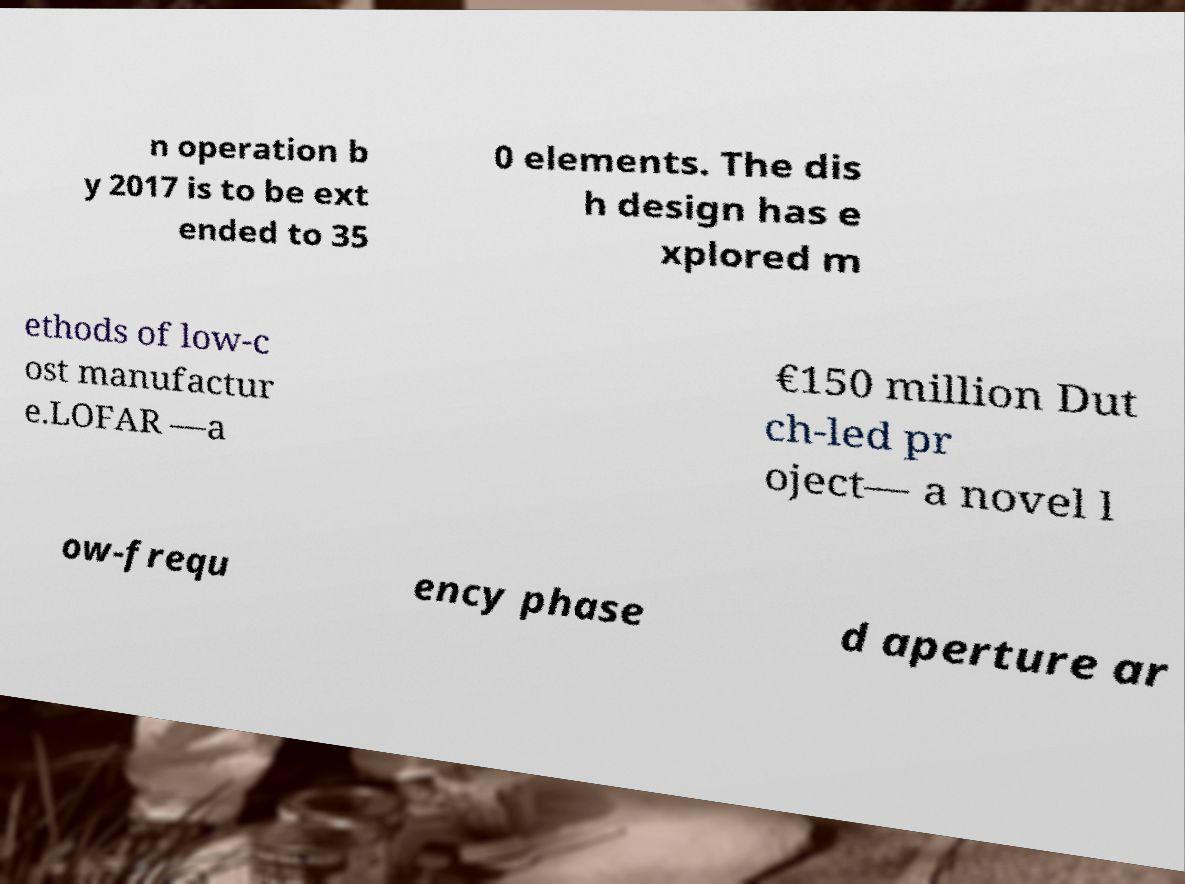Could you extract and type out the text from this image? n operation b y 2017 is to be ext ended to 35 0 elements. The dis h design has e xplored m ethods of low-c ost manufactur e.LOFAR —a €150 million Dut ch-led pr oject— a novel l ow-frequ ency phase d aperture ar 